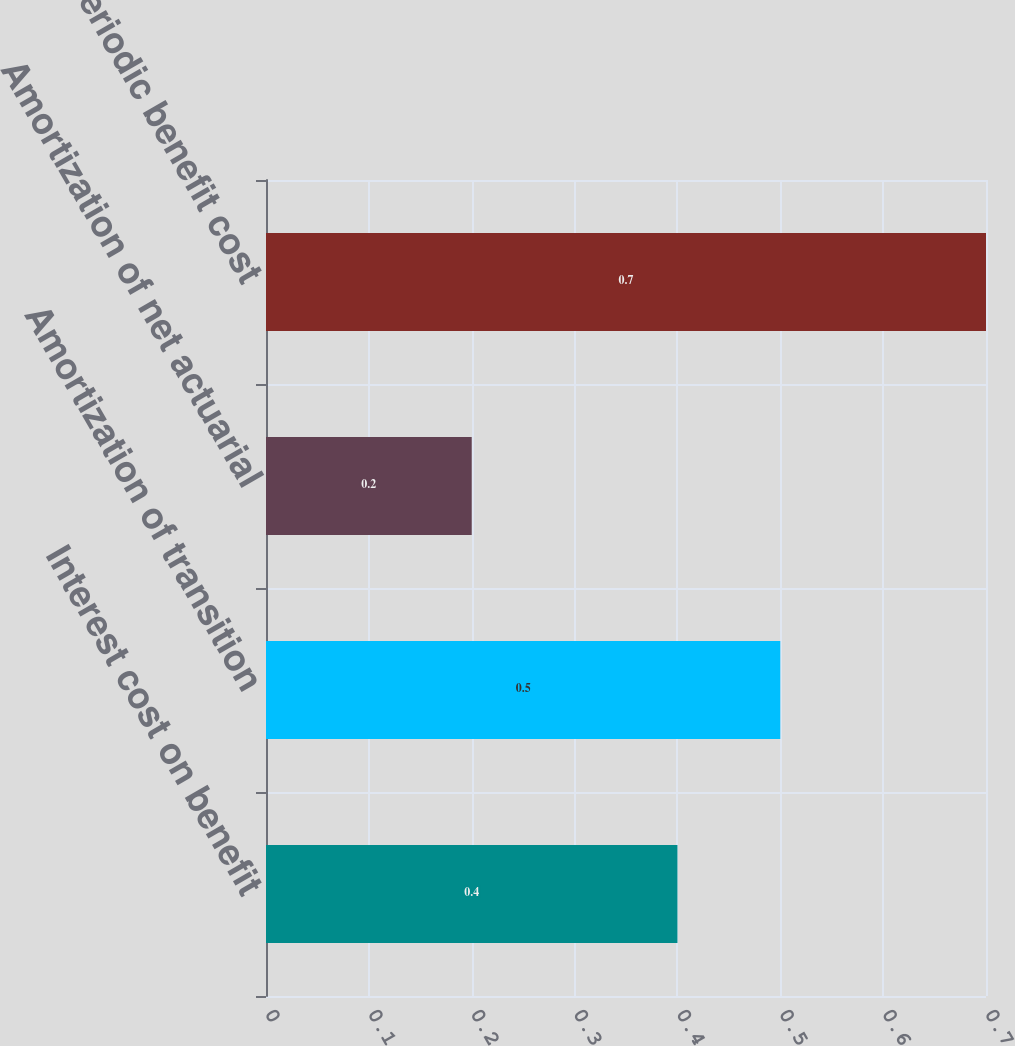Convert chart. <chart><loc_0><loc_0><loc_500><loc_500><bar_chart><fcel>Interest cost on benefit<fcel>Amortization of transition<fcel>Amortization of net actuarial<fcel>Net periodic benefit cost<nl><fcel>0.4<fcel>0.5<fcel>0.2<fcel>0.7<nl></chart> 